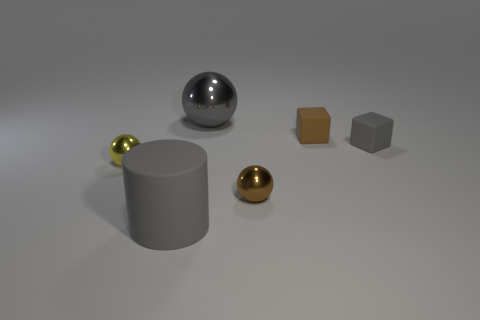How big is the block behind the gray matte object that is behind the small yellow sphere?
Offer a terse response. Small. Are there any big purple cylinders made of the same material as the small gray block?
Keep it short and to the point. No. What material is the gray thing that is the same size as the brown rubber cube?
Provide a succinct answer. Rubber. There is a block that is on the right side of the brown cube; does it have the same color as the large object to the right of the big rubber cylinder?
Give a very brief answer. Yes. Are there any big cylinders in front of the metallic ball that is right of the big sphere?
Offer a terse response. Yes. There is a brown thing that is behind the tiny brown shiny sphere; is it the same shape as the gray rubber object that is right of the gray matte cylinder?
Keep it short and to the point. Yes. Do the large gray object behind the tiny yellow object and the tiny sphere that is right of the big gray cylinder have the same material?
Your answer should be compact. Yes. There is a small sphere in front of the tiny sphere that is behind the brown shiny ball; what is it made of?
Your answer should be very brief. Metal. What is the shape of the large gray thing behind the big gray thing in front of the small shiny sphere that is on the right side of the gray rubber cylinder?
Your response must be concise. Sphere. There is a gray thing that is the same shape as the brown rubber thing; what is it made of?
Your response must be concise. Rubber. 